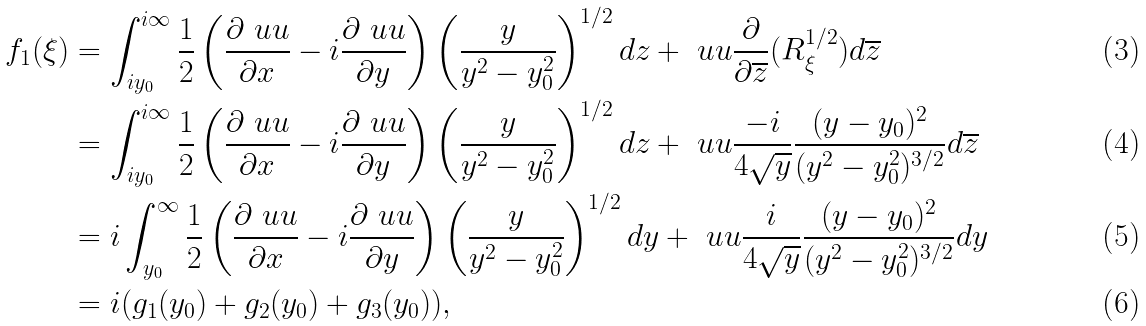<formula> <loc_0><loc_0><loc_500><loc_500>f _ { 1 } ( \xi ) & = \int ^ { i \infty } _ { i y _ { 0 } } \frac { 1 } { 2 } \left ( \frac { \partial \ u u } { \partial x } - i \frac { \partial \ u u } { \partial y } \right ) \left ( \frac { y } { y ^ { 2 } - y _ { 0 } ^ { 2 } } \right ) ^ { 1 / 2 } d z + \ u u \frac { \partial } { \partial \overline { z } } ( R ^ { 1 / 2 } _ { \xi } ) d \overline { z } \\ & = \int ^ { i \infty } _ { i y _ { 0 } } \frac { 1 } { 2 } \left ( \frac { \partial \ u u } { \partial x } - i \frac { \partial \ u u } { \partial y } \right ) \left ( \frac { y } { y ^ { 2 } - y _ { 0 } ^ { 2 } } \right ) ^ { 1 / 2 } d z + \ u u \frac { - i } { 4 \sqrt { y } } \frac { ( y - y _ { 0 } ) ^ { 2 } } { ( y ^ { 2 } - y ^ { 2 } _ { 0 } ) ^ { 3 / 2 } } d \overline { z } \\ & = i \int ^ { \infty } _ { y _ { 0 } } \frac { 1 } { 2 } \left ( \frac { \partial \ u u } { \partial x } - i \frac { \partial \ u u } { \partial y } \right ) \left ( \frac { y } { y ^ { 2 } - y _ { 0 } ^ { 2 } } \right ) ^ { 1 / 2 } d y + \ u u \frac { i } { 4 \sqrt { y } } \frac { ( y - y _ { 0 } ) ^ { 2 } } { ( y ^ { 2 } - y ^ { 2 } _ { 0 } ) ^ { 3 / 2 } } d y \\ & = i ( g _ { 1 } ( y _ { 0 } ) + g _ { 2 } ( y _ { 0 } ) + g _ { 3 } ( y _ { 0 } ) ) ,</formula> 